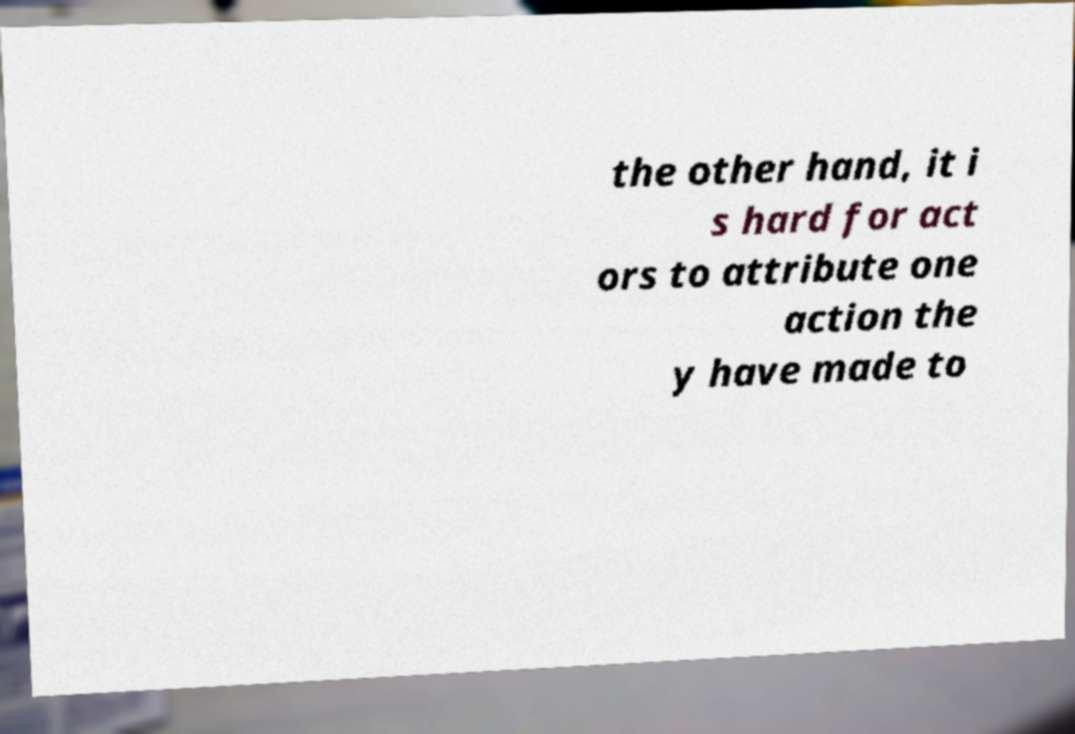Could you extract and type out the text from this image? the other hand, it i s hard for act ors to attribute one action the y have made to 